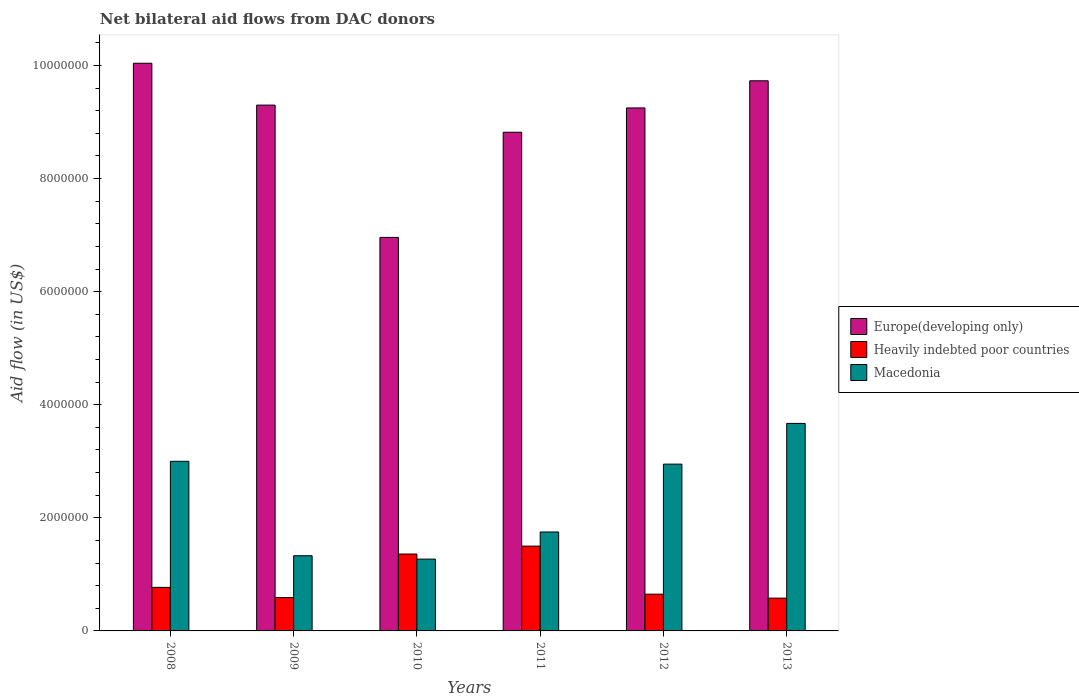How many groups of bars are there?
Your answer should be compact. 6. Are the number of bars per tick equal to the number of legend labels?
Provide a succinct answer. Yes. In how many cases, is the number of bars for a given year not equal to the number of legend labels?
Provide a short and direct response. 0. What is the net bilateral aid flow in Heavily indebted poor countries in 2008?
Your response must be concise. 7.70e+05. Across all years, what is the maximum net bilateral aid flow in Macedonia?
Offer a very short reply. 3.67e+06. Across all years, what is the minimum net bilateral aid flow in Heavily indebted poor countries?
Provide a succinct answer. 5.80e+05. In which year was the net bilateral aid flow in Europe(developing only) maximum?
Keep it short and to the point. 2008. In which year was the net bilateral aid flow in Europe(developing only) minimum?
Provide a short and direct response. 2010. What is the total net bilateral aid flow in Europe(developing only) in the graph?
Provide a short and direct response. 5.41e+07. What is the difference between the net bilateral aid flow in Macedonia in 2008 and that in 2010?
Make the answer very short. 1.73e+06. What is the difference between the net bilateral aid flow in Macedonia in 2011 and the net bilateral aid flow in Heavily indebted poor countries in 2010?
Offer a very short reply. 3.90e+05. What is the average net bilateral aid flow in Heavily indebted poor countries per year?
Your response must be concise. 9.08e+05. In the year 2008, what is the difference between the net bilateral aid flow in Europe(developing only) and net bilateral aid flow in Heavily indebted poor countries?
Offer a terse response. 9.27e+06. What is the ratio of the net bilateral aid flow in Heavily indebted poor countries in 2009 to that in 2012?
Offer a very short reply. 0.91. Is the net bilateral aid flow in Macedonia in 2010 less than that in 2012?
Offer a terse response. Yes. What is the difference between the highest and the second highest net bilateral aid flow in Macedonia?
Provide a succinct answer. 6.70e+05. What is the difference between the highest and the lowest net bilateral aid flow in Europe(developing only)?
Make the answer very short. 3.08e+06. In how many years, is the net bilateral aid flow in Heavily indebted poor countries greater than the average net bilateral aid flow in Heavily indebted poor countries taken over all years?
Offer a terse response. 2. What does the 2nd bar from the left in 2011 represents?
Your answer should be very brief. Heavily indebted poor countries. What does the 1st bar from the right in 2010 represents?
Keep it short and to the point. Macedonia. How many bars are there?
Your answer should be very brief. 18. What is the difference between two consecutive major ticks on the Y-axis?
Keep it short and to the point. 2.00e+06. Does the graph contain any zero values?
Give a very brief answer. No. Where does the legend appear in the graph?
Your answer should be very brief. Center right. How many legend labels are there?
Keep it short and to the point. 3. How are the legend labels stacked?
Provide a succinct answer. Vertical. What is the title of the graph?
Provide a short and direct response. Net bilateral aid flows from DAC donors. Does "South Sudan" appear as one of the legend labels in the graph?
Provide a succinct answer. No. What is the label or title of the Y-axis?
Offer a very short reply. Aid flow (in US$). What is the Aid flow (in US$) of Europe(developing only) in 2008?
Provide a short and direct response. 1.00e+07. What is the Aid flow (in US$) in Heavily indebted poor countries in 2008?
Keep it short and to the point. 7.70e+05. What is the Aid flow (in US$) in Europe(developing only) in 2009?
Provide a short and direct response. 9.30e+06. What is the Aid flow (in US$) of Heavily indebted poor countries in 2009?
Your answer should be compact. 5.90e+05. What is the Aid flow (in US$) of Macedonia in 2009?
Keep it short and to the point. 1.33e+06. What is the Aid flow (in US$) of Europe(developing only) in 2010?
Offer a terse response. 6.96e+06. What is the Aid flow (in US$) of Heavily indebted poor countries in 2010?
Keep it short and to the point. 1.36e+06. What is the Aid flow (in US$) of Macedonia in 2010?
Keep it short and to the point. 1.27e+06. What is the Aid flow (in US$) of Europe(developing only) in 2011?
Ensure brevity in your answer.  8.82e+06. What is the Aid flow (in US$) in Heavily indebted poor countries in 2011?
Your response must be concise. 1.50e+06. What is the Aid flow (in US$) of Macedonia in 2011?
Keep it short and to the point. 1.75e+06. What is the Aid flow (in US$) of Europe(developing only) in 2012?
Provide a succinct answer. 9.25e+06. What is the Aid flow (in US$) in Heavily indebted poor countries in 2012?
Provide a short and direct response. 6.50e+05. What is the Aid flow (in US$) in Macedonia in 2012?
Offer a terse response. 2.95e+06. What is the Aid flow (in US$) of Europe(developing only) in 2013?
Provide a short and direct response. 9.73e+06. What is the Aid flow (in US$) in Heavily indebted poor countries in 2013?
Make the answer very short. 5.80e+05. What is the Aid flow (in US$) of Macedonia in 2013?
Offer a terse response. 3.67e+06. Across all years, what is the maximum Aid flow (in US$) in Europe(developing only)?
Keep it short and to the point. 1.00e+07. Across all years, what is the maximum Aid flow (in US$) in Heavily indebted poor countries?
Offer a very short reply. 1.50e+06. Across all years, what is the maximum Aid flow (in US$) of Macedonia?
Your answer should be compact. 3.67e+06. Across all years, what is the minimum Aid flow (in US$) of Europe(developing only)?
Offer a terse response. 6.96e+06. Across all years, what is the minimum Aid flow (in US$) in Heavily indebted poor countries?
Offer a terse response. 5.80e+05. Across all years, what is the minimum Aid flow (in US$) in Macedonia?
Provide a succinct answer. 1.27e+06. What is the total Aid flow (in US$) of Europe(developing only) in the graph?
Your answer should be compact. 5.41e+07. What is the total Aid flow (in US$) of Heavily indebted poor countries in the graph?
Provide a succinct answer. 5.45e+06. What is the total Aid flow (in US$) of Macedonia in the graph?
Offer a terse response. 1.40e+07. What is the difference between the Aid flow (in US$) of Europe(developing only) in 2008 and that in 2009?
Offer a very short reply. 7.40e+05. What is the difference between the Aid flow (in US$) in Macedonia in 2008 and that in 2009?
Your response must be concise. 1.67e+06. What is the difference between the Aid flow (in US$) in Europe(developing only) in 2008 and that in 2010?
Give a very brief answer. 3.08e+06. What is the difference between the Aid flow (in US$) in Heavily indebted poor countries in 2008 and that in 2010?
Offer a very short reply. -5.90e+05. What is the difference between the Aid flow (in US$) of Macedonia in 2008 and that in 2010?
Your answer should be compact. 1.73e+06. What is the difference between the Aid flow (in US$) in Europe(developing only) in 2008 and that in 2011?
Your answer should be compact. 1.22e+06. What is the difference between the Aid flow (in US$) of Heavily indebted poor countries in 2008 and that in 2011?
Make the answer very short. -7.30e+05. What is the difference between the Aid flow (in US$) of Macedonia in 2008 and that in 2011?
Keep it short and to the point. 1.25e+06. What is the difference between the Aid flow (in US$) of Europe(developing only) in 2008 and that in 2012?
Give a very brief answer. 7.90e+05. What is the difference between the Aid flow (in US$) of Heavily indebted poor countries in 2008 and that in 2012?
Make the answer very short. 1.20e+05. What is the difference between the Aid flow (in US$) in Macedonia in 2008 and that in 2012?
Provide a succinct answer. 5.00e+04. What is the difference between the Aid flow (in US$) of Heavily indebted poor countries in 2008 and that in 2013?
Provide a succinct answer. 1.90e+05. What is the difference between the Aid flow (in US$) in Macedonia in 2008 and that in 2013?
Provide a succinct answer. -6.70e+05. What is the difference between the Aid flow (in US$) in Europe(developing only) in 2009 and that in 2010?
Your answer should be very brief. 2.34e+06. What is the difference between the Aid flow (in US$) in Heavily indebted poor countries in 2009 and that in 2010?
Offer a terse response. -7.70e+05. What is the difference between the Aid flow (in US$) in Heavily indebted poor countries in 2009 and that in 2011?
Ensure brevity in your answer.  -9.10e+05. What is the difference between the Aid flow (in US$) of Macedonia in 2009 and that in 2011?
Make the answer very short. -4.20e+05. What is the difference between the Aid flow (in US$) in Heavily indebted poor countries in 2009 and that in 2012?
Offer a terse response. -6.00e+04. What is the difference between the Aid flow (in US$) in Macedonia in 2009 and that in 2012?
Your answer should be very brief. -1.62e+06. What is the difference between the Aid flow (in US$) of Europe(developing only) in 2009 and that in 2013?
Ensure brevity in your answer.  -4.30e+05. What is the difference between the Aid flow (in US$) in Macedonia in 2009 and that in 2013?
Your response must be concise. -2.34e+06. What is the difference between the Aid flow (in US$) in Europe(developing only) in 2010 and that in 2011?
Ensure brevity in your answer.  -1.86e+06. What is the difference between the Aid flow (in US$) of Heavily indebted poor countries in 2010 and that in 2011?
Your answer should be compact. -1.40e+05. What is the difference between the Aid flow (in US$) in Macedonia in 2010 and that in 2011?
Provide a short and direct response. -4.80e+05. What is the difference between the Aid flow (in US$) of Europe(developing only) in 2010 and that in 2012?
Provide a succinct answer. -2.29e+06. What is the difference between the Aid flow (in US$) of Heavily indebted poor countries in 2010 and that in 2012?
Your answer should be very brief. 7.10e+05. What is the difference between the Aid flow (in US$) in Macedonia in 2010 and that in 2012?
Make the answer very short. -1.68e+06. What is the difference between the Aid flow (in US$) of Europe(developing only) in 2010 and that in 2013?
Keep it short and to the point. -2.77e+06. What is the difference between the Aid flow (in US$) in Heavily indebted poor countries in 2010 and that in 2013?
Ensure brevity in your answer.  7.80e+05. What is the difference between the Aid flow (in US$) in Macedonia in 2010 and that in 2013?
Give a very brief answer. -2.40e+06. What is the difference between the Aid flow (in US$) of Europe(developing only) in 2011 and that in 2012?
Your response must be concise. -4.30e+05. What is the difference between the Aid flow (in US$) in Heavily indebted poor countries in 2011 and that in 2012?
Your answer should be very brief. 8.50e+05. What is the difference between the Aid flow (in US$) in Macedonia in 2011 and that in 2012?
Keep it short and to the point. -1.20e+06. What is the difference between the Aid flow (in US$) of Europe(developing only) in 2011 and that in 2013?
Provide a short and direct response. -9.10e+05. What is the difference between the Aid flow (in US$) in Heavily indebted poor countries in 2011 and that in 2013?
Your answer should be compact. 9.20e+05. What is the difference between the Aid flow (in US$) of Macedonia in 2011 and that in 2013?
Make the answer very short. -1.92e+06. What is the difference between the Aid flow (in US$) in Europe(developing only) in 2012 and that in 2013?
Keep it short and to the point. -4.80e+05. What is the difference between the Aid flow (in US$) of Macedonia in 2012 and that in 2013?
Provide a succinct answer. -7.20e+05. What is the difference between the Aid flow (in US$) in Europe(developing only) in 2008 and the Aid flow (in US$) in Heavily indebted poor countries in 2009?
Offer a very short reply. 9.45e+06. What is the difference between the Aid flow (in US$) in Europe(developing only) in 2008 and the Aid flow (in US$) in Macedonia in 2009?
Your answer should be compact. 8.71e+06. What is the difference between the Aid flow (in US$) of Heavily indebted poor countries in 2008 and the Aid flow (in US$) of Macedonia in 2009?
Your answer should be very brief. -5.60e+05. What is the difference between the Aid flow (in US$) of Europe(developing only) in 2008 and the Aid flow (in US$) of Heavily indebted poor countries in 2010?
Keep it short and to the point. 8.68e+06. What is the difference between the Aid flow (in US$) of Europe(developing only) in 2008 and the Aid flow (in US$) of Macedonia in 2010?
Make the answer very short. 8.77e+06. What is the difference between the Aid flow (in US$) in Heavily indebted poor countries in 2008 and the Aid flow (in US$) in Macedonia in 2010?
Ensure brevity in your answer.  -5.00e+05. What is the difference between the Aid flow (in US$) of Europe(developing only) in 2008 and the Aid flow (in US$) of Heavily indebted poor countries in 2011?
Provide a short and direct response. 8.54e+06. What is the difference between the Aid flow (in US$) of Europe(developing only) in 2008 and the Aid flow (in US$) of Macedonia in 2011?
Give a very brief answer. 8.29e+06. What is the difference between the Aid flow (in US$) of Heavily indebted poor countries in 2008 and the Aid flow (in US$) of Macedonia in 2011?
Offer a terse response. -9.80e+05. What is the difference between the Aid flow (in US$) of Europe(developing only) in 2008 and the Aid flow (in US$) of Heavily indebted poor countries in 2012?
Give a very brief answer. 9.39e+06. What is the difference between the Aid flow (in US$) in Europe(developing only) in 2008 and the Aid flow (in US$) in Macedonia in 2012?
Ensure brevity in your answer.  7.09e+06. What is the difference between the Aid flow (in US$) in Heavily indebted poor countries in 2008 and the Aid flow (in US$) in Macedonia in 2012?
Your answer should be very brief. -2.18e+06. What is the difference between the Aid flow (in US$) in Europe(developing only) in 2008 and the Aid flow (in US$) in Heavily indebted poor countries in 2013?
Provide a succinct answer. 9.46e+06. What is the difference between the Aid flow (in US$) in Europe(developing only) in 2008 and the Aid flow (in US$) in Macedonia in 2013?
Provide a short and direct response. 6.37e+06. What is the difference between the Aid flow (in US$) in Heavily indebted poor countries in 2008 and the Aid flow (in US$) in Macedonia in 2013?
Give a very brief answer. -2.90e+06. What is the difference between the Aid flow (in US$) of Europe(developing only) in 2009 and the Aid flow (in US$) of Heavily indebted poor countries in 2010?
Provide a succinct answer. 7.94e+06. What is the difference between the Aid flow (in US$) of Europe(developing only) in 2009 and the Aid flow (in US$) of Macedonia in 2010?
Your response must be concise. 8.03e+06. What is the difference between the Aid flow (in US$) of Heavily indebted poor countries in 2009 and the Aid flow (in US$) of Macedonia in 2010?
Give a very brief answer. -6.80e+05. What is the difference between the Aid flow (in US$) in Europe(developing only) in 2009 and the Aid flow (in US$) in Heavily indebted poor countries in 2011?
Offer a very short reply. 7.80e+06. What is the difference between the Aid flow (in US$) in Europe(developing only) in 2009 and the Aid flow (in US$) in Macedonia in 2011?
Your answer should be very brief. 7.55e+06. What is the difference between the Aid flow (in US$) in Heavily indebted poor countries in 2009 and the Aid flow (in US$) in Macedonia in 2011?
Ensure brevity in your answer.  -1.16e+06. What is the difference between the Aid flow (in US$) in Europe(developing only) in 2009 and the Aid flow (in US$) in Heavily indebted poor countries in 2012?
Offer a very short reply. 8.65e+06. What is the difference between the Aid flow (in US$) in Europe(developing only) in 2009 and the Aid flow (in US$) in Macedonia in 2012?
Your answer should be very brief. 6.35e+06. What is the difference between the Aid flow (in US$) of Heavily indebted poor countries in 2009 and the Aid flow (in US$) of Macedonia in 2012?
Your answer should be very brief. -2.36e+06. What is the difference between the Aid flow (in US$) of Europe(developing only) in 2009 and the Aid flow (in US$) of Heavily indebted poor countries in 2013?
Ensure brevity in your answer.  8.72e+06. What is the difference between the Aid flow (in US$) of Europe(developing only) in 2009 and the Aid flow (in US$) of Macedonia in 2013?
Offer a very short reply. 5.63e+06. What is the difference between the Aid flow (in US$) in Heavily indebted poor countries in 2009 and the Aid flow (in US$) in Macedonia in 2013?
Ensure brevity in your answer.  -3.08e+06. What is the difference between the Aid flow (in US$) in Europe(developing only) in 2010 and the Aid flow (in US$) in Heavily indebted poor countries in 2011?
Provide a succinct answer. 5.46e+06. What is the difference between the Aid flow (in US$) in Europe(developing only) in 2010 and the Aid flow (in US$) in Macedonia in 2011?
Keep it short and to the point. 5.21e+06. What is the difference between the Aid flow (in US$) in Heavily indebted poor countries in 2010 and the Aid flow (in US$) in Macedonia in 2011?
Offer a very short reply. -3.90e+05. What is the difference between the Aid flow (in US$) of Europe(developing only) in 2010 and the Aid flow (in US$) of Heavily indebted poor countries in 2012?
Ensure brevity in your answer.  6.31e+06. What is the difference between the Aid flow (in US$) of Europe(developing only) in 2010 and the Aid flow (in US$) of Macedonia in 2012?
Offer a terse response. 4.01e+06. What is the difference between the Aid flow (in US$) in Heavily indebted poor countries in 2010 and the Aid flow (in US$) in Macedonia in 2012?
Your response must be concise. -1.59e+06. What is the difference between the Aid flow (in US$) of Europe(developing only) in 2010 and the Aid flow (in US$) of Heavily indebted poor countries in 2013?
Offer a terse response. 6.38e+06. What is the difference between the Aid flow (in US$) of Europe(developing only) in 2010 and the Aid flow (in US$) of Macedonia in 2013?
Give a very brief answer. 3.29e+06. What is the difference between the Aid flow (in US$) in Heavily indebted poor countries in 2010 and the Aid flow (in US$) in Macedonia in 2013?
Your answer should be very brief. -2.31e+06. What is the difference between the Aid flow (in US$) of Europe(developing only) in 2011 and the Aid flow (in US$) of Heavily indebted poor countries in 2012?
Offer a very short reply. 8.17e+06. What is the difference between the Aid flow (in US$) of Europe(developing only) in 2011 and the Aid flow (in US$) of Macedonia in 2012?
Your response must be concise. 5.87e+06. What is the difference between the Aid flow (in US$) of Heavily indebted poor countries in 2011 and the Aid flow (in US$) of Macedonia in 2012?
Keep it short and to the point. -1.45e+06. What is the difference between the Aid flow (in US$) in Europe(developing only) in 2011 and the Aid flow (in US$) in Heavily indebted poor countries in 2013?
Offer a terse response. 8.24e+06. What is the difference between the Aid flow (in US$) of Europe(developing only) in 2011 and the Aid flow (in US$) of Macedonia in 2013?
Provide a short and direct response. 5.15e+06. What is the difference between the Aid flow (in US$) of Heavily indebted poor countries in 2011 and the Aid flow (in US$) of Macedonia in 2013?
Provide a short and direct response. -2.17e+06. What is the difference between the Aid flow (in US$) of Europe(developing only) in 2012 and the Aid flow (in US$) of Heavily indebted poor countries in 2013?
Give a very brief answer. 8.67e+06. What is the difference between the Aid flow (in US$) in Europe(developing only) in 2012 and the Aid flow (in US$) in Macedonia in 2013?
Make the answer very short. 5.58e+06. What is the difference between the Aid flow (in US$) in Heavily indebted poor countries in 2012 and the Aid flow (in US$) in Macedonia in 2013?
Provide a succinct answer. -3.02e+06. What is the average Aid flow (in US$) of Europe(developing only) per year?
Ensure brevity in your answer.  9.02e+06. What is the average Aid flow (in US$) of Heavily indebted poor countries per year?
Provide a short and direct response. 9.08e+05. What is the average Aid flow (in US$) of Macedonia per year?
Offer a terse response. 2.33e+06. In the year 2008, what is the difference between the Aid flow (in US$) of Europe(developing only) and Aid flow (in US$) of Heavily indebted poor countries?
Make the answer very short. 9.27e+06. In the year 2008, what is the difference between the Aid flow (in US$) of Europe(developing only) and Aid flow (in US$) of Macedonia?
Your answer should be very brief. 7.04e+06. In the year 2008, what is the difference between the Aid flow (in US$) of Heavily indebted poor countries and Aid flow (in US$) of Macedonia?
Offer a very short reply. -2.23e+06. In the year 2009, what is the difference between the Aid flow (in US$) of Europe(developing only) and Aid flow (in US$) of Heavily indebted poor countries?
Provide a short and direct response. 8.71e+06. In the year 2009, what is the difference between the Aid flow (in US$) in Europe(developing only) and Aid flow (in US$) in Macedonia?
Provide a short and direct response. 7.97e+06. In the year 2009, what is the difference between the Aid flow (in US$) in Heavily indebted poor countries and Aid flow (in US$) in Macedonia?
Your response must be concise. -7.40e+05. In the year 2010, what is the difference between the Aid flow (in US$) in Europe(developing only) and Aid flow (in US$) in Heavily indebted poor countries?
Offer a terse response. 5.60e+06. In the year 2010, what is the difference between the Aid flow (in US$) of Europe(developing only) and Aid flow (in US$) of Macedonia?
Provide a short and direct response. 5.69e+06. In the year 2011, what is the difference between the Aid flow (in US$) of Europe(developing only) and Aid flow (in US$) of Heavily indebted poor countries?
Offer a terse response. 7.32e+06. In the year 2011, what is the difference between the Aid flow (in US$) of Europe(developing only) and Aid flow (in US$) of Macedonia?
Give a very brief answer. 7.07e+06. In the year 2012, what is the difference between the Aid flow (in US$) in Europe(developing only) and Aid flow (in US$) in Heavily indebted poor countries?
Offer a terse response. 8.60e+06. In the year 2012, what is the difference between the Aid flow (in US$) of Europe(developing only) and Aid flow (in US$) of Macedonia?
Give a very brief answer. 6.30e+06. In the year 2012, what is the difference between the Aid flow (in US$) of Heavily indebted poor countries and Aid flow (in US$) of Macedonia?
Your response must be concise. -2.30e+06. In the year 2013, what is the difference between the Aid flow (in US$) in Europe(developing only) and Aid flow (in US$) in Heavily indebted poor countries?
Give a very brief answer. 9.15e+06. In the year 2013, what is the difference between the Aid flow (in US$) of Europe(developing only) and Aid flow (in US$) of Macedonia?
Keep it short and to the point. 6.06e+06. In the year 2013, what is the difference between the Aid flow (in US$) in Heavily indebted poor countries and Aid flow (in US$) in Macedonia?
Provide a short and direct response. -3.09e+06. What is the ratio of the Aid flow (in US$) in Europe(developing only) in 2008 to that in 2009?
Your response must be concise. 1.08. What is the ratio of the Aid flow (in US$) of Heavily indebted poor countries in 2008 to that in 2009?
Ensure brevity in your answer.  1.31. What is the ratio of the Aid flow (in US$) of Macedonia in 2008 to that in 2009?
Your answer should be very brief. 2.26. What is the ratio of the Aid flow (in US$) in Europe(developing only) in 2008 to that in 2010?
Offer a very short reply. 1.44. What is the ratio of the Aid flow (in US$) in Heavily indebted poor countries in 2008 to that in 2010?
Provide a succinct answer. 0.57. What is the ratio of the Aid flow (in US$) of Macedonia in 2008 to that in 2010?
Offer a terse response. 2.36. What is the ratio of the Aid flow (in US$) in Europe(developing only) in 2008 to that in 2011?
Offer a terse response. 1.14. What is the ratio of the Aid flow (in US$) in Heavily indebted poor countries in 2008 to that in 2011?
Your response must be concise. 0.51. What is the ratio of the Aid flow (in US$) in Macedonia in 2008 to that in 2011?
Ensure brevity in your answer.  1.71. What is the ratio of the Aid flow (in US$) of Europe(developing only) in 2008 to that in 2012?
Keep it short and to the point. 1.09. What is the ratio of the Aid flow (in US$) of Heavily indebted poor countries in 2008 to that in 2012?
Offer a very short reply. 1.18. What is the ratio of the Aid flow (in US$) in Macedonia in 2008 to that in 2012?
Give a very brief answer. 1.02. What is the ratio of the Aid flow (in US$) in Europe(developing only) in 2008 to that in 2013?
Give a very brief answer. 1.03. What is the ratio of the Aid flow (in US$) in Heavily indebted poor countries in 2008 to that in 2013?
Give a very brief answer. 1.33. What is the ratio of the Aid flow (in US$) of Macedonia in 2008 to that in 2013?
Provide a succinct answer. 0.82. What is the ratio of the Aid flow (in US$) in Europe(developing only) in 2009 to that in 2010?
Keep it short and to the point. 1.34. What is the ratio of the Aid flow (in US$) in Heavily indebted poor countries in 2009 to that in 2010?
Your answer should be compact. 0.43. What is the ratio of the Aid flow (in US$) in Macedonia in 2009 to that in 2010?
Offer a terse response. 1.05. What is the ratio of the Aid flow (in US$) of Europe(developing only) in 2009 to that in 2011?
Your answer should be compact. 1.05. What is the ratio of the Aid flow (in US$) in Heavily indebted poor countries in 2009 to that in 2011?
Your answer should be very brief. 0.39. What is the ratio of the Aid flow (in US$) in Macedonia in 2009 to that in 2011?
Provide a short and direct response. 0.76. What is the ratio of the Aid flow (in US$) in Europe(developing only) in 2009 to that in 2012?
Offer a very short reply. 1.01. What is the ratio of the Aid flow (in US$) in Heavily indebted poor countries in 2009 to that in 2012?
Provide a short and direct response. 0.91. What is the ratio of the Aid flow (in US$) in Macedonia in 2009 to that in 2012?
Keep it short and to the point. 0.45. What is the ratio of the Aid flow (in US$) of Europe(developing only) in 2009 to that in 2013?
Provide a succinct answer. 0.96. What is the ratio of the Aid flow (in US$) of Heavily indebted poor countries in 2009 to that in 2013?
Provide a short and direct response. 1.02. What is the ratio of the Aid flow (in US$) in Macedonia in 2009 to that in 2013?
Your answer should be very brief. 0.36. What is the ratio of the Aid flow (in US$) in Europe(developing only) in 2010 to that in 2011?
Provide a succinct answer. 0.79. What is the ratio of the Aid flow (in US$) in Heavily indebted poor countries in 2010 to that in 2011?
Make the answer very short. 0.91. What is the ratio of the Aid flow (in US$) of Macedonia in 2010 to that in 2011?
Keep it short and to the point. 0.73. What is the ratio of the Aid flow (in US$) in Europe(developing only) in 2010 to that in 2012?
Offer a very short reply. 0.75. What is the ratio of the Aid flow (in US$) of Heavily indebted poor countries in 2010 to that in 2012?
Keep it short and to the point. 2.09. What is the ratio of the Aid flow (in US$) in Macedonia in 2010 to that in 2012?
Your answer should be very brief. 0.43. What is the ratio of the Aid flow (in US$) in Europe(developing only) in 2010 to that in 2013?
Keep it short and to the point. 0.72. What is the ratio of the Aid flow (in US$) in Heavily indebted poor countries in 2010 to that in 2013?
Keep it short and to the point. 2.34. What is the ratio of the Aid flow (in US$) in Macedonia in 2010 to that in 2013?
Ensure brevity in your answer.  0.35. What is the ratio of the Aid flow (in US$) in Europe(developing only) in 2011 to that in 2012?
Offer a very short reply. 0.95. What is the ratio of the Aid flow (in US$) in Heavily indebted poor countries in 2011 to that in 2012?
Make the answer very short. 2.31. What is the ratio of the Aid flow (in US$) in Macedonia in 2011 to that in 2012?
Your answer should be very brief. 0.59. What is the ratio of the Aid flow (in US$) of Europe(developing only) in 2011 to that in 2013?
Your answer should be very brief. 0.91. What is the ratio of the Aid flow (in US$) of Heavily indebted poor countries in 2011 to that in 2013?
Your response must be concise. 2.59. What is the ratio of the Aid flow (in US$) of Macedonia in 2011 to that in 2013?
Ensure brevity in your answer.  0.48. What is the ratio of the Aid flow (in US$) of Europe(developing only) in 2012 to that in 2013?
Your answer should be compact. 0.95. What is the ratio of the Aid flow (in US$) of Heavily indebted poor countries in 2012 to that in 2013?
Make the answer very short. 1.12. What is the ratio of the Aid flow (in US$) in Macedonia in 2012 to that in 2013?
Your response must be concise. 0.8. What is the difference between the highest and the second highest Aid flow (in US$) in Macedonia?
Offer a terse response. 6.70e+05. What is the difference between the highest and the lowest Aid flow (in US$) of Europe(developing only)?
Keep it short and to the point. 3.08e+06. What is the difference between the highest and the lowest Aid flow (in US$) of Heavily indebted poor countries?
Make the answer very short. 9.20e+05. What is the difference between the highest and the lowest Aid flow (in US$) of Macedonia?
Make the answer very short. 2.40e+06. 